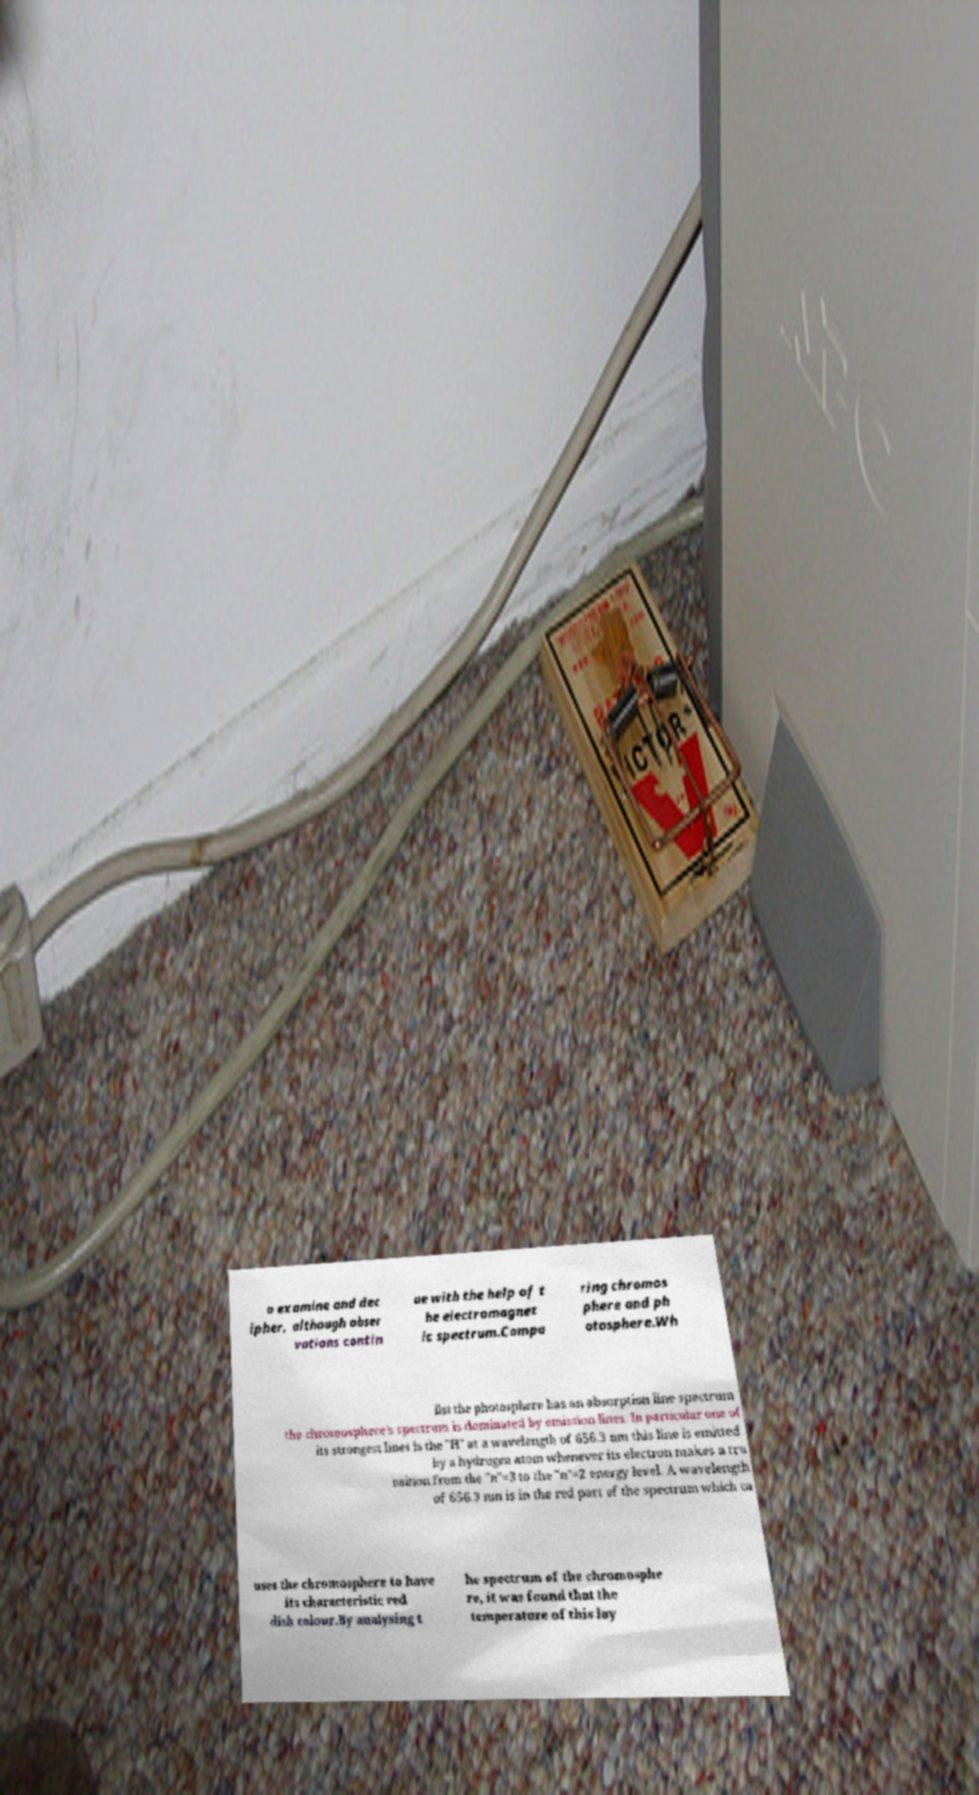For documentation purposes, I need the text within this image transcribed. Could you provide that? o examine and dec ipher, although obser vations contin ue with the help of t he electromagnet ic spectrum.Compa ring chromos phere and ph otosphere.Wh ilst the photosphere has an absorption line spectrum the chromosphere's spectrum is dominated by emission lines. In particular one of its strongest lines is the "H" at a wavelength of 656.3 nm this line is emitted by a hydrogen atom whenever its electron makes a tra nsition from the "n"=3 to the "n"=2 energy level. A wavelength of 656.3 nm is in the red part of the spectrum which ca uses the chromosphere to have its characteristic red dish colour.By analysing t he spectrum of the chromosphe re, it was found that the temperature of this lay 